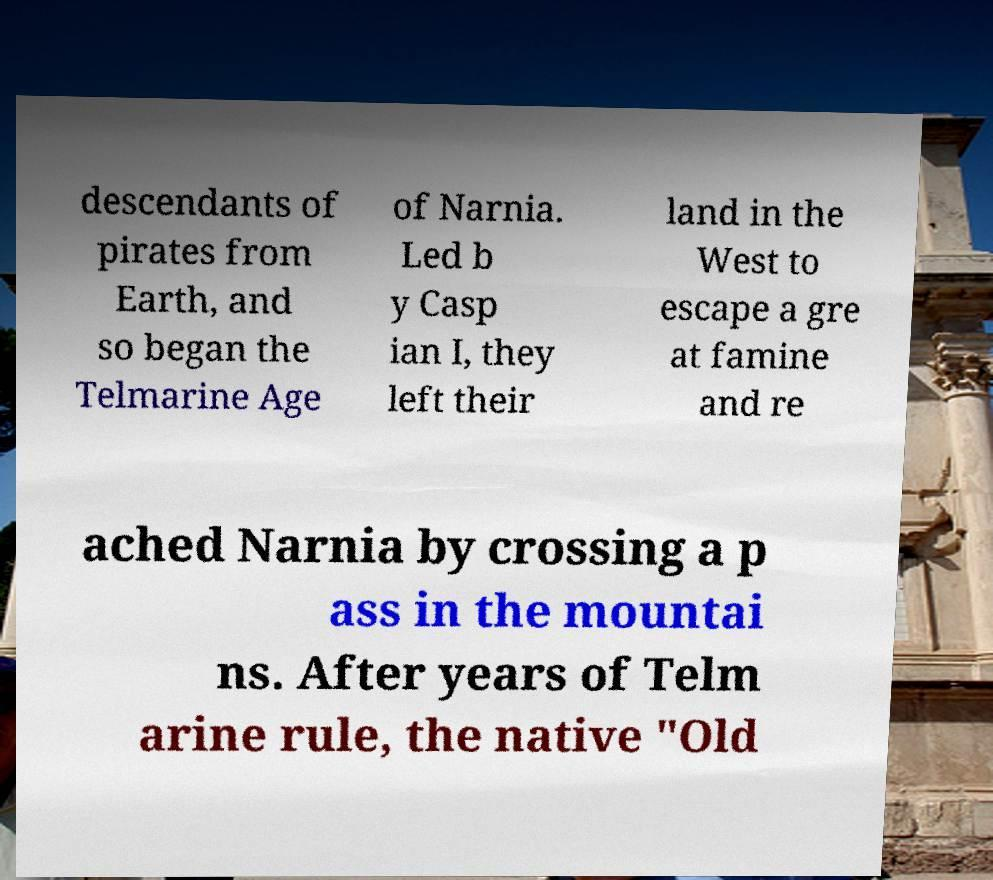Could you assist in decoding the text presented in this image and type it out clearly? descendants of pirates from Earth, and so began the Telmarine Age of Narnia. Led b y Casp ian I, they left their land in the West to escape a gre at famine and re ached Narnia by crossing a p ass in the mountai ns. After years of Telm arine rule, the native "Old 